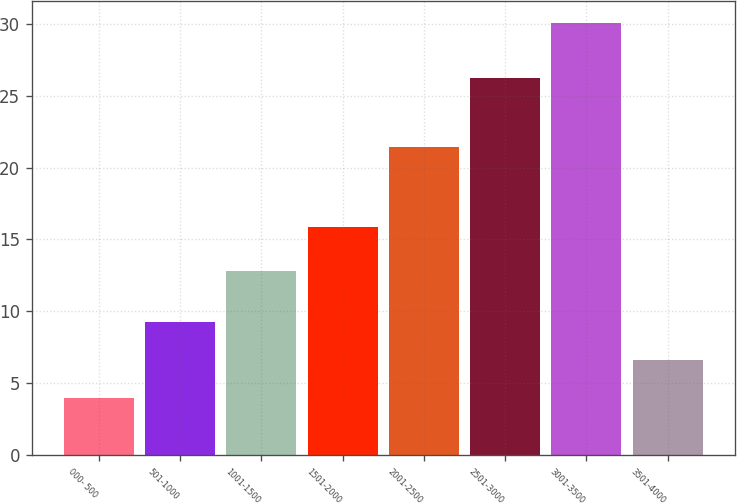<chart> <loc_0><loc_0><loc_500><loc_500><bar_chart><fcel>000- 500<fcel>501-1000<fcel>1001-1500<fcel>1501-2000<fcel>2001-2500<fcel>2501-3000<fcel>3001-3500<fcel>3501-4000<nl><fcel>4.01<fcel>9.23<fcel>12.8<fcel>15.84<fcel>21.43<fcel>26.23<fcel>30.07<fcel>6.62<nl></chart> 